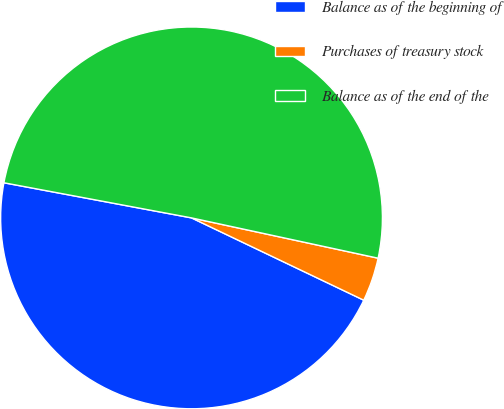Convert chart to OTSL. <chart><loc_0><loc_0><loc_500><loc_500><pie_chart><fcel>Balance as of the beginning of<fcel>Purchases of treasury stock<fcel>Balance as of the end of the<nl><fcel>45.85%<fcel>3.71%<fcel>50.44%<nl></chart> 